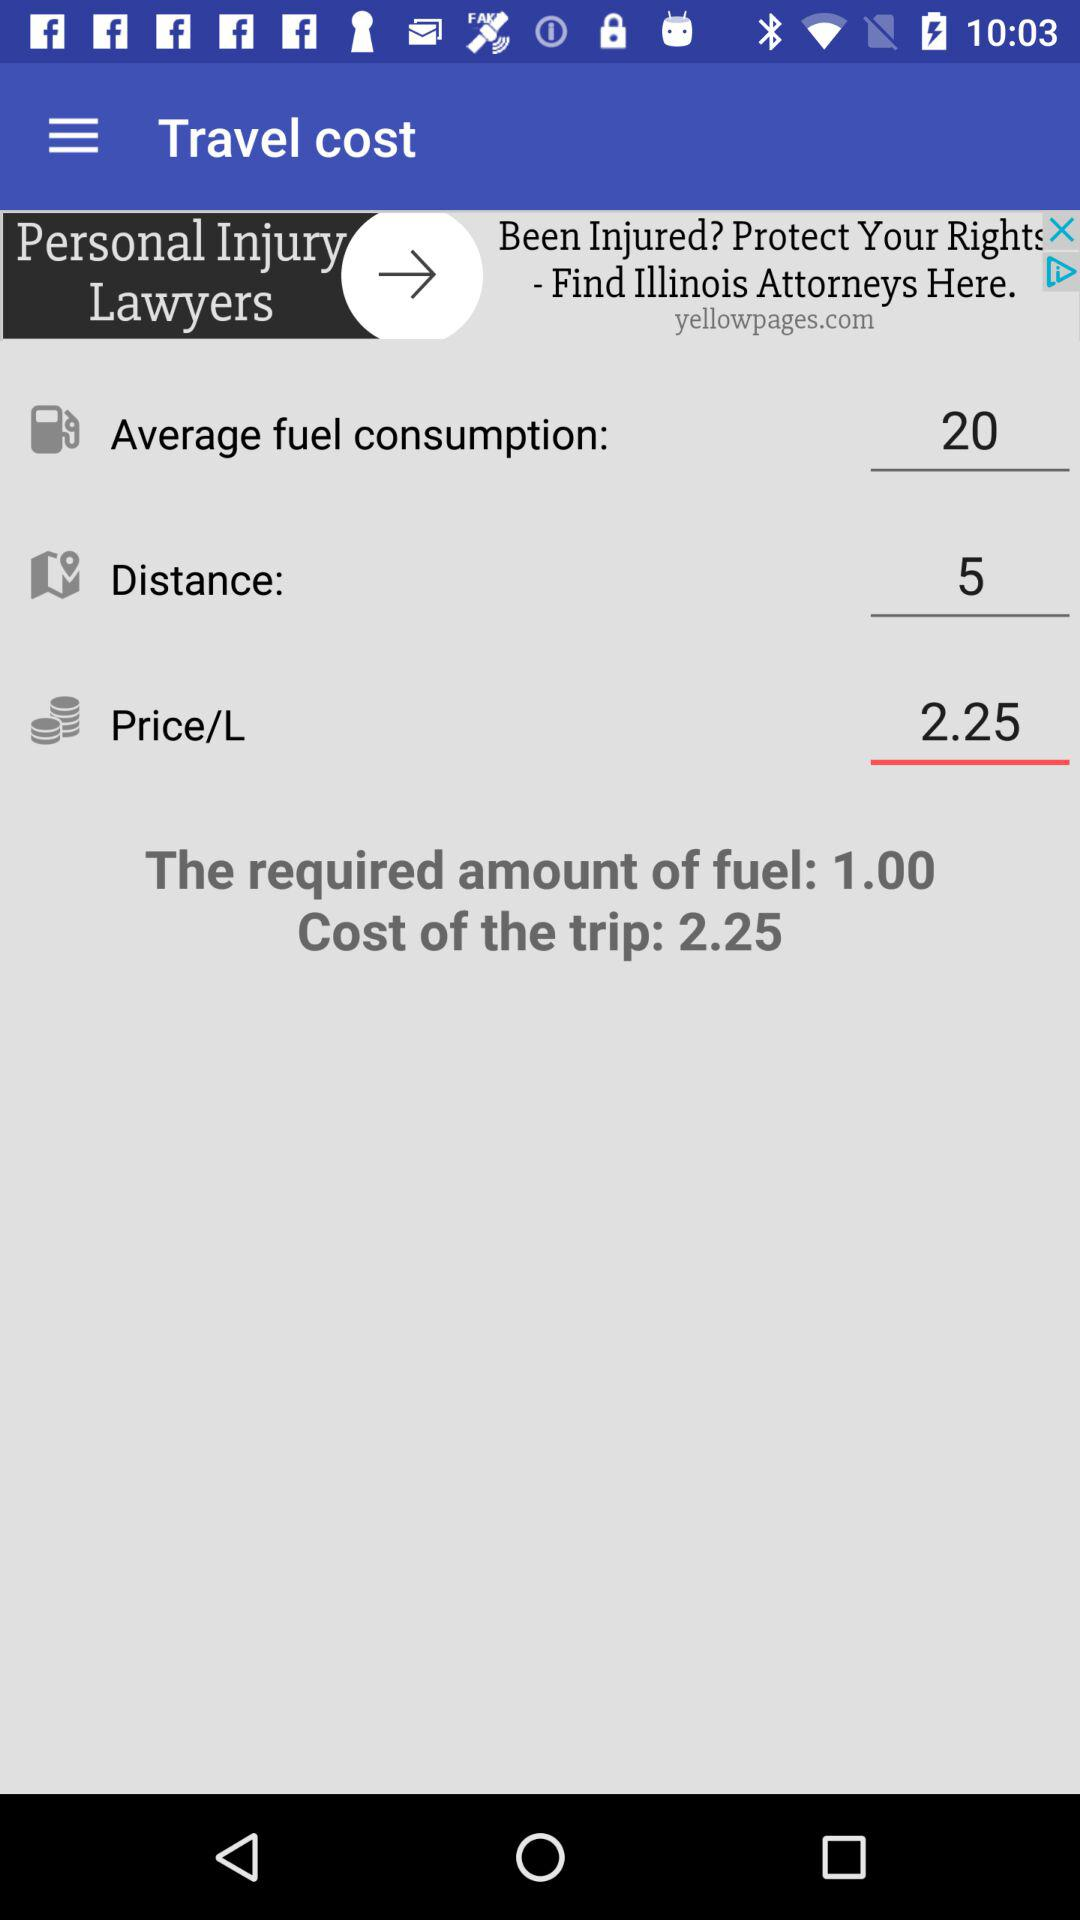What is the cost of the trip? The cost of the trip is 2.25. 